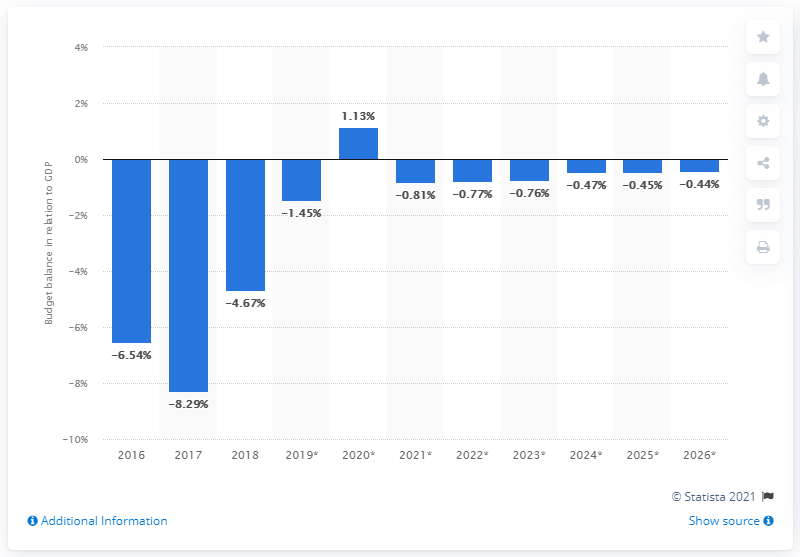Give some essential details in this illustration. Zimbabwe's budget balance in relation to GDP ended in 2018. 